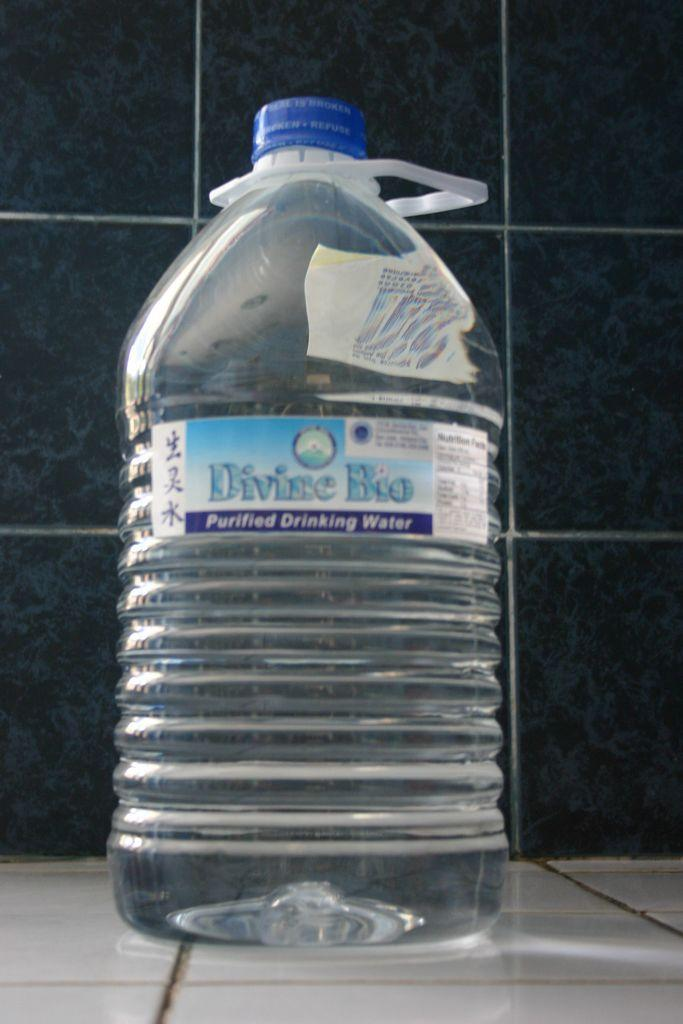<image>
Relay a brief, clear account of the picture shown. A large bottle of Divine Bio water has a blue cap. 